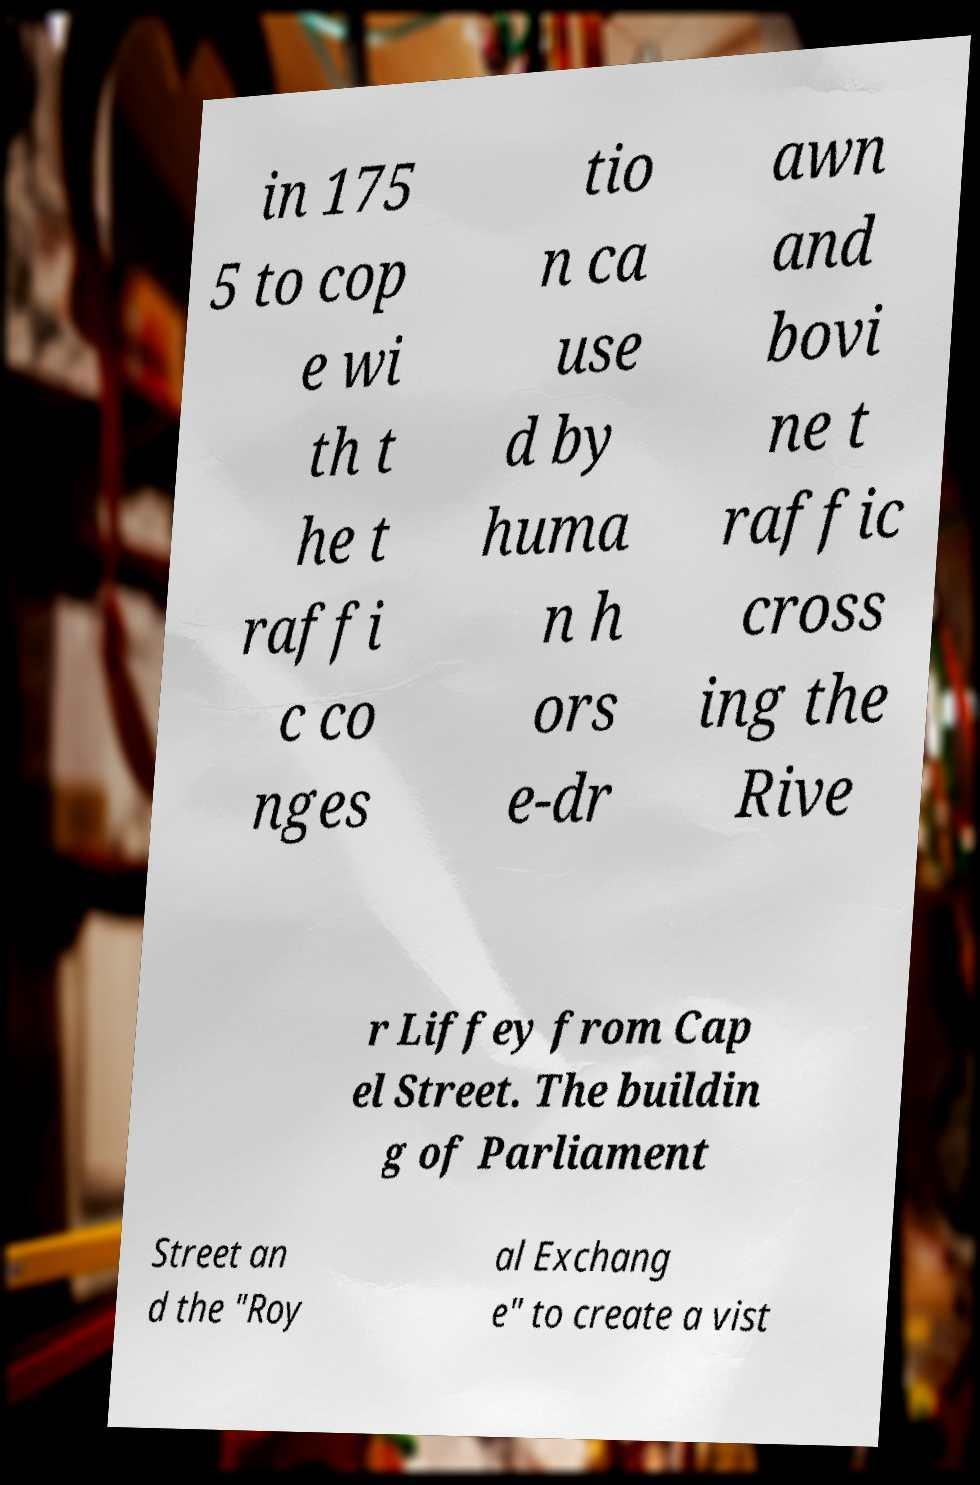What messages or text are displayed in this image? I need them in a readable, typed format. in 175 5 to cop e wi th t he t raffi c co nges tio n ca use d by huma n h ors e-dr awn and bovi ne t raffic cross ing the Rive r Liffey from Cap el Street. The buildin g of Parliament Street an d the "Roy al Exchang e" to create a vist 